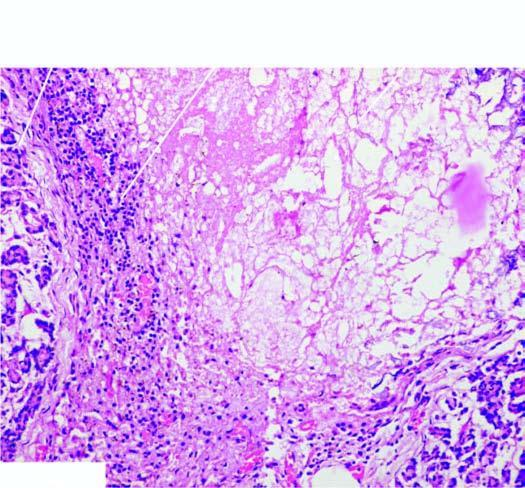what is the necrotic tissue surrounded by?
Answer the question using a single word or phrase. Mixed inflammatory infiltrate with granulation tissue formation 